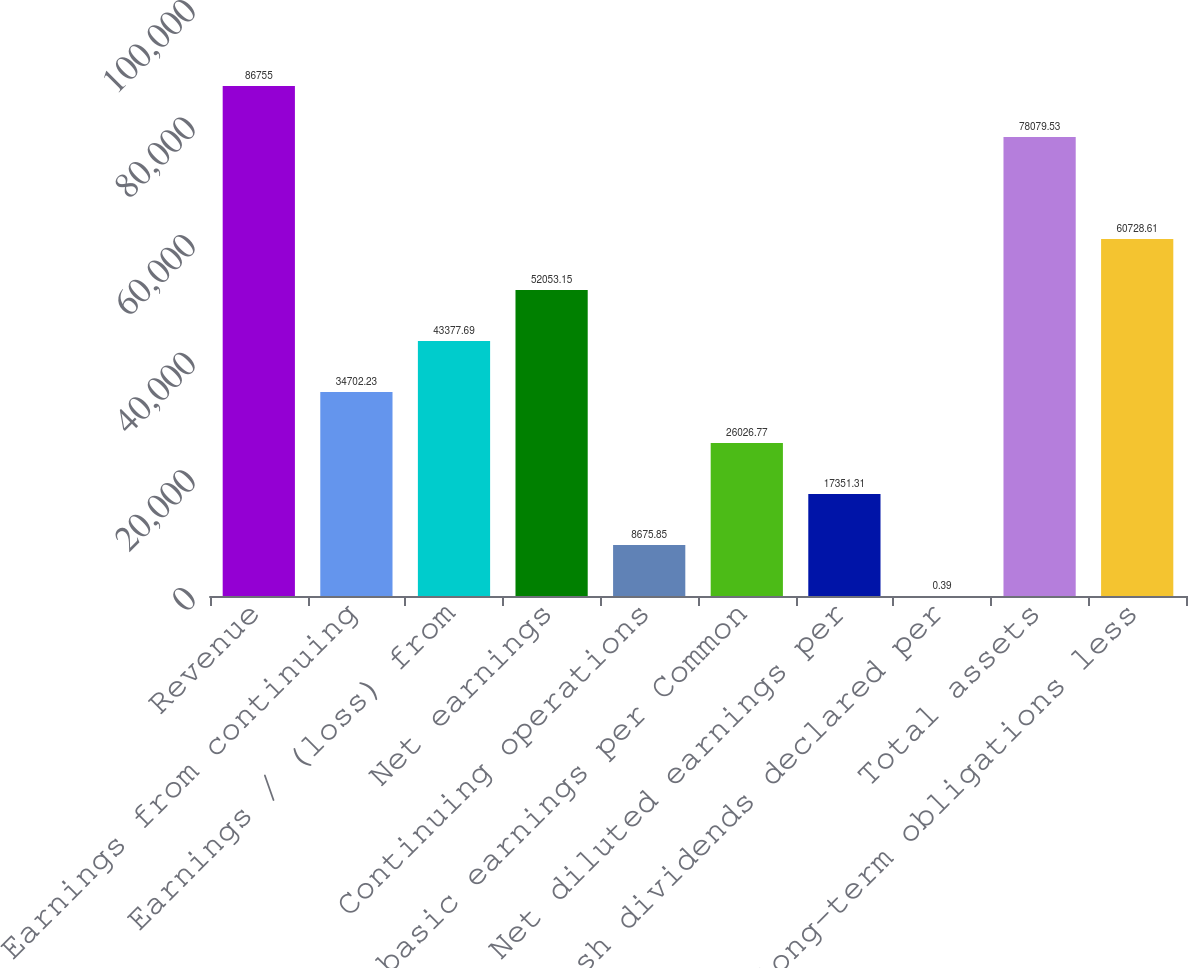<chart> <loc_0><loc_0><loc_500><loc_500><bar_chart><fcel>Revenue<fcel>Earnings from continuing<fcel>Earnings / (loss) from<fcel>Net earnings<fcel>Continuing operations<fcel>Net basic earnings per Common<fcel>Net diluted earnings per<fcel>Cash dividends declared per<fcel>Total assets<fcel>Long-term obligations less<nl><fcel>86755<fcel>34702.2<fcel>43377.7<fcel>52053.2<fcel>8675.85<fcel>26026.8<fcel>17351.3<fcel>0.39<fcel>78079.5<fcel>60728.6<nl></chart> 